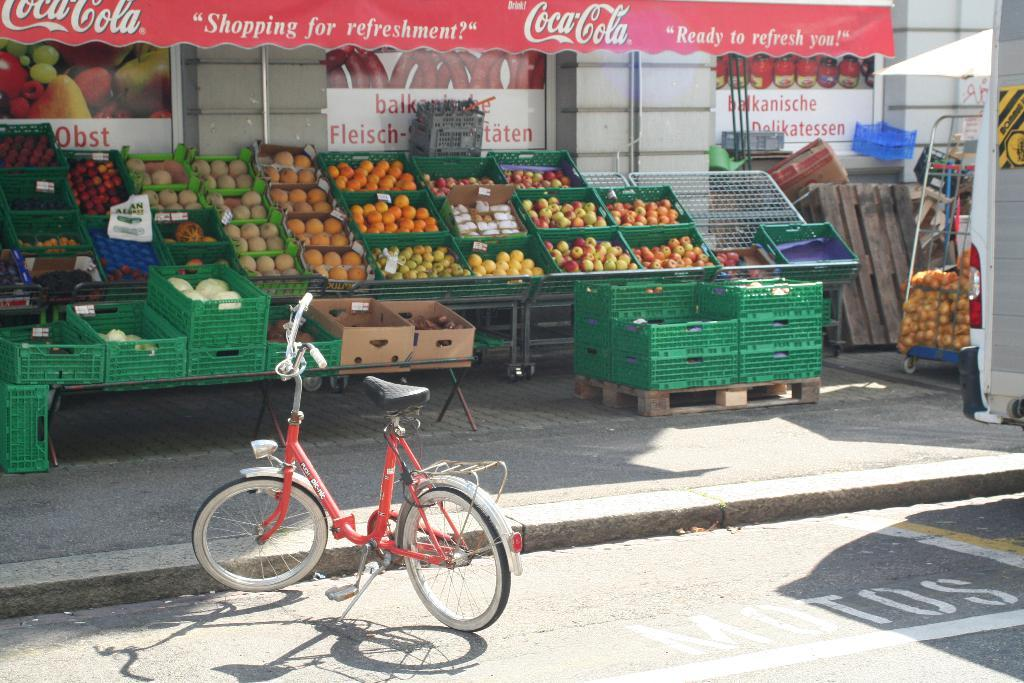Provide a one-sentence caption for the provided image. An awning with Coca Cola on it hangs above cartons of fruit in an outdoor market. 